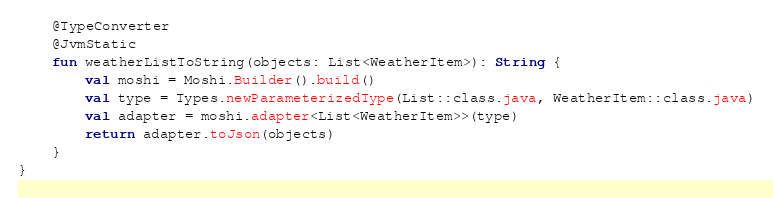<code> <loc_0><loc_0><loc_500><loc_500><_Kotlin_>
    @TypeConverter
    @JvmStatic
    fun weatherListToString(objects: List<WeatherItem>): String {
        val moshi = Moshi.Builder().build()
        val type = Types.newParameterizedType(List::class.java, WeatherItem::class.java)
        val adapter = moshi.adapter<List<WeatherItem>>(type)
        return adapter.toJson(objects)
    }
}
</code> 